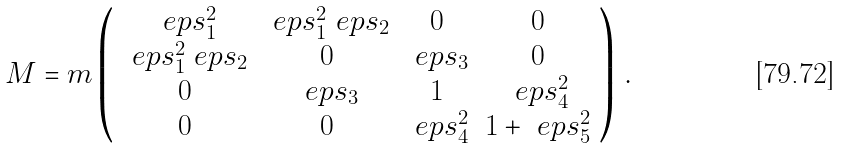Convert formula to latex. <formula><loc_0><loc_0><loc_500><loc_500>M = m \left ( \begin{array} { c c c c } \ e p s _ { 1 } ^ { 2 } & \ e p s _ { 1 } ^ { 2 } \ e p s _ { 2 } & 0 & 0 \\ \ e p s _ { 1 } ^ { 2 } \ e p s _ { 2 } & 0 & \ e p s _ { 3 } & 0 \\ 0 & \ e p s _ { 3 } & 1 & \ e p s _ { 4 } ^ { 2 } \\ 0 & 0 & \ e p s _ { 4 } ^ { 2 } & 1 + \ e p s _ { 5 } ^ { 2 } \end{array} \right ) \, .</formula> 